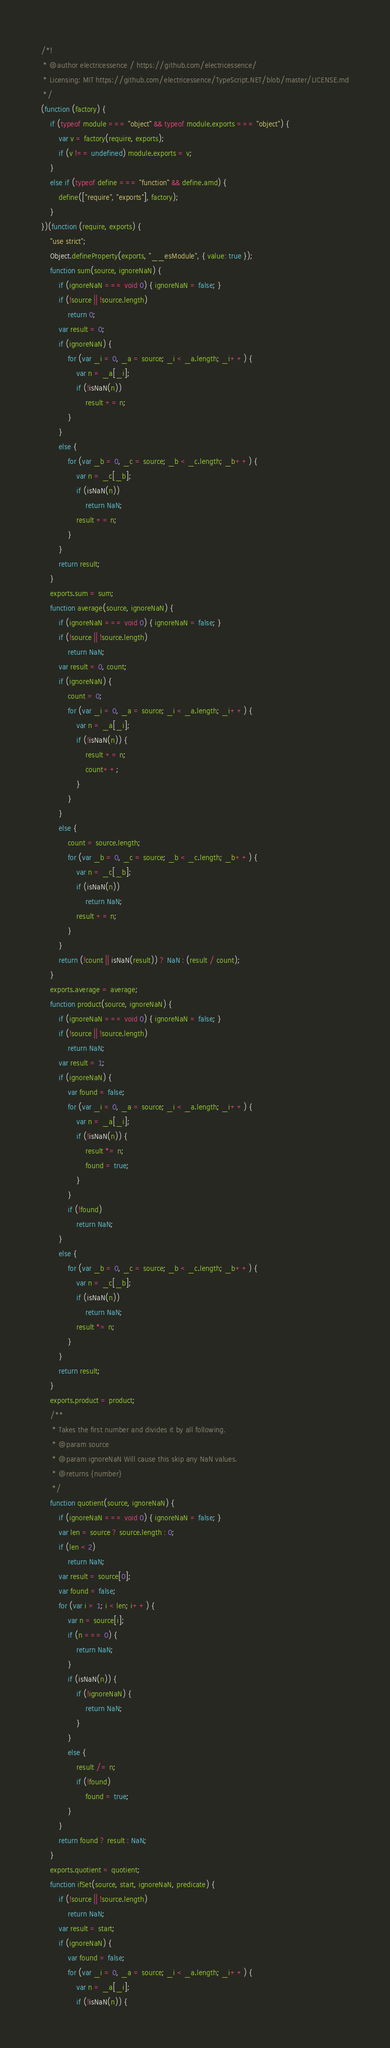<code> <loc_0><loc_0><loc_500><loc_500><_JavaScript_>/*!
 * @author electricessence / https://github.com/electricessence/
 * Licensing: MIT https://github.com/electricessence/TypeScript.NET/blob/master/LICENSE.md
 */
(function (factory) {
    if (typeof module === "object" && typeof module.exports === "object") {
        var v = factory(require, exports);
        if (v !== undefined) module.exports = v;
    }
    else if (typeof define === "function" && define.amd) {
        define(["require", "exports"], factory);
    }
})(function (require, exports) {
    "use strict";
    Object.defineProperty(exports, "__esModule", { value: true });
    function sum(source, ignoreNaN) {
        if (ignoreNaN === void 0) { ignoreNaN = false; }
        if (!source || !source.length)
            return 0;
        var result = 0;
        if (ignoreNaN) {
            for (var _i = 0, _a = source; _i < _a.length; _i++) {
                var n = _a[_i];
                if (!isNaN(n))
                    result += n;
            }
        }
        else {
            for (var _b = 0, _c = source; _b < _c.length; _b++) {
                var n = _c[_b];
                if (isNaN(n))
                    return NaN;
                result += n;
            }
        }
        return result;
    }
    exports.sum = sum;
    function average(source, ignoreNaN) {
        if (ignoreNaN === void 0) { ignoreNaN = false; }
        if (!source || !source.length)
            return NaN;
        var result = 0, count;
        if (ignoreNaN) {
            count = 0;
            for (var _i = 0, _a = source; _i < _a.length; _i++) {
                var n = _a[_i];
                if (!isNaN(n)) {
                    result += n;
                    count++;
                }
            }
        }
        else {
            count = source.length;
            for (var _b = 0, _c = source; _b < _c.length; _b++) {
                var n = _c[_b];
                if (isNaN(n))
                    return NaN;
                result += n;
            }
        }
        return (!count || isNaN(result)) ? NaN : (result / count);
    }
    exports.average = average;
    function product(source, ignoreNaN) {
        if (ignoreNaN === void 0) { ignoreNaN = false; }
        if (!source || !source.length)
            return NaN;
        var result = 1;
        if (ignoreNaN) {
            var found = false;
            for (var _i = 0, _a = source; _i < _a.length; _i++) {
                var n = _a[_i];
                if (!isNaN(n)) {
                    result *= n;
                    found = true;
                }
            }
            if (!found)
                return NaN;
        }
        else {
            for (var _b = 0, _c = source; _b < _c.length; _b++) {
                var n = _c[_b];
                if (isNaN(n))
                    return NaN;
                result *= n;
            }
        }
        return result;
    }
    exports.product = product;
    /**
     * Takes the first number and divides it by all following.
     * @param source
     * @param ignoreNaN Will cause this skip any NaN values.
     * @returns {number}
     */
    function quotient(source, ignoreNaN) {
        if (ignoreNaN === void 0) { ignoreNaN = false; }
        var len = source ? source.length : 0;
        if (len < 2)
            return NaN;
        var result = source[0];
        var found = false;
        for (var i = 1; i < len; i++) {
            var n = source[i];
            if (n === 0) {
                return NaN;
            }
            if (isNaN(n)) {
                if (!ignoreNaN) {
                    return NaN;
                }
            }
            else {
                result /= n;
                if (!found)
                    found = true;
            }
        }
        return found ? result : NaN;
    }
    exports.quotient = quotient;
    function ifSet(source, start, ignoreNaN, predicate) {
        if (!source || !source.length)
            return NaN;
        var result = start;
        if (ignoreNaN) {
            var found = false;
            for (var _i = 0, _a = source; _i < _a.length; _i++) {
                var n = _a[_i];
                if (!isNaN(n)) {</code> 